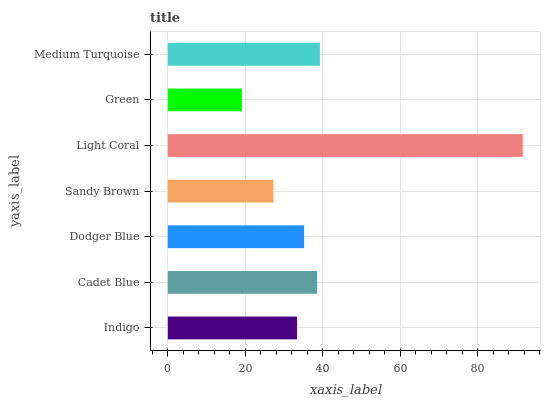Is Green the minimum?
Answer yes or no. Yes. Is Light Coral the maximum?
Answer yes or no. Yes. Is Cadet Blue the minimum?
Answer yes or no. No. Is Cadet Blue the maximum?
Answer yes or no. No. Is Cadet Blue greater than Indigo?
Answer yes or no. Yes. Is Indigo less than Cadet Blue?
Answer yes or no. Yes. Is Indigo greater than Cadet Blue?
Answer yes or no. No. Is Cadet Blue less than Indigo?
Answer yes or no. No. Is Dodger Blue the high median?
Answer yes or no. Yes. Is Dodger Blue the low median?
Answer yes or no. Yes. Is Medium Turquoise the high median?
Answer yes or no. No. Is Cadet Blue the low median?
Answer yes or no. No. 